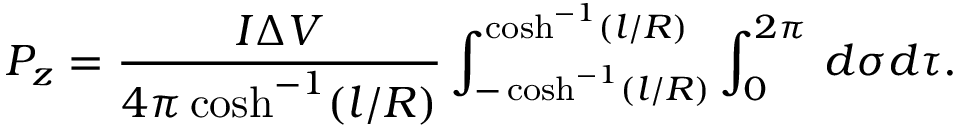<formula> <loc_0><loc_0><loc_500><loc_500>P _ { z } = \frac { I \Delta V } { 4 \pi \cosh ^ { - 1 } ( l / R ) } \int _ { - \cosh ^ { - 1 } ( l / R ) } ^ { \cosh ^ { - 1 } ( l / R ) } \int _ { 0 } ^ { 2 \pi } \, d \sigma d \tau .</formula> 